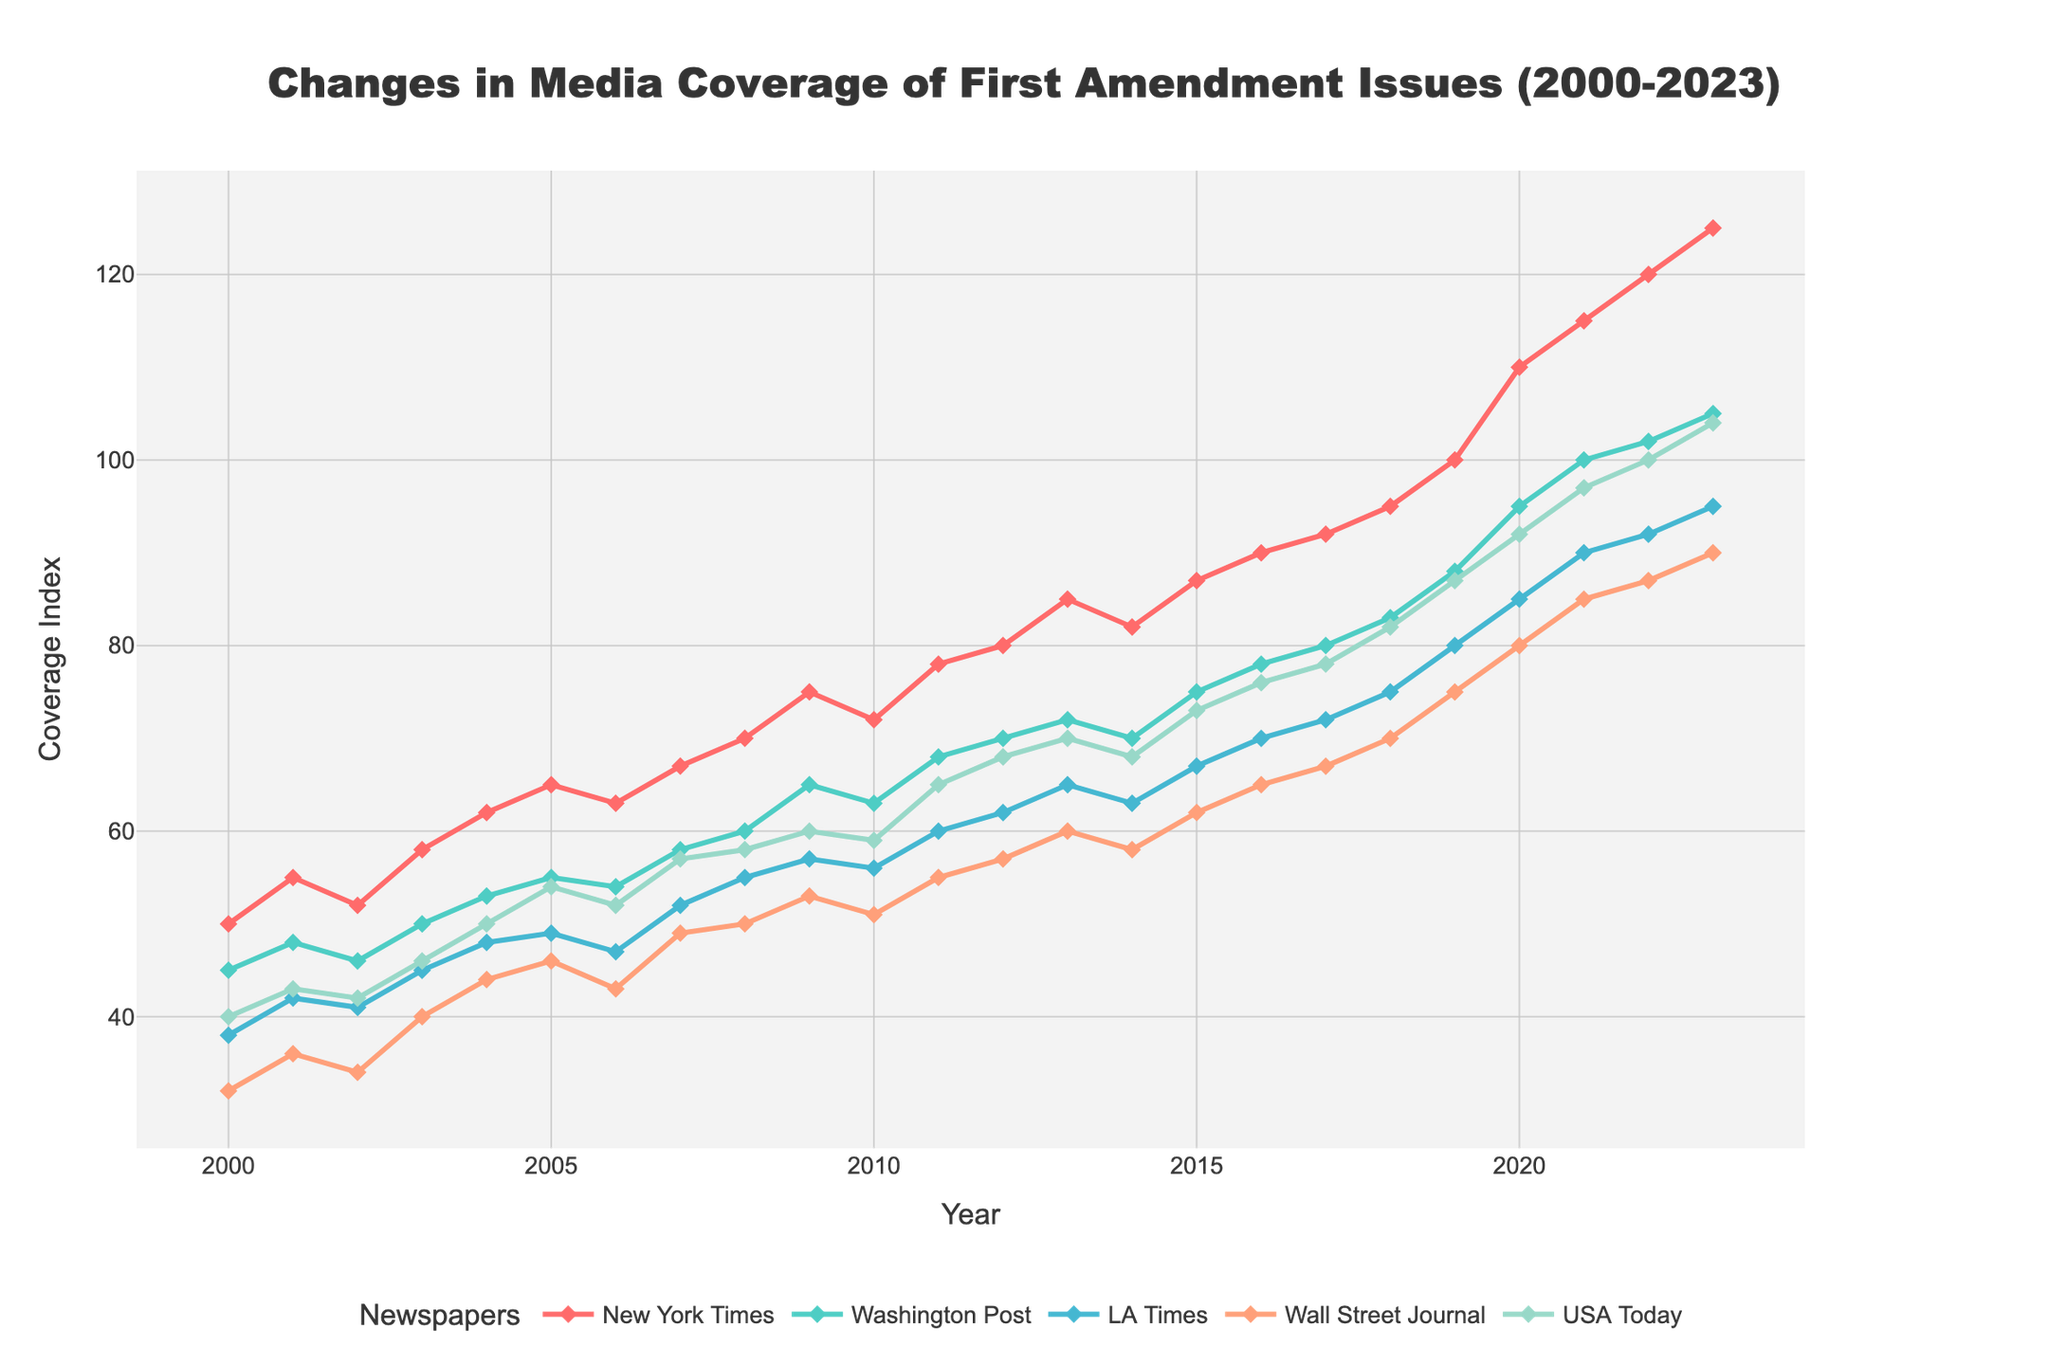what is the title of the plot? The title is located at the top of the plot and provides a summary of what the plot is about. It reads "Changes in Media Coverage of First Amendment Issues (2000-2023)".
Answer: Changes in Media Coverage of First Amendment Issues (2000-2023) What was the coverage index of the New York Times in 2005? Locate the year 2005 on the x-axis and trace it vertically to find the corresponding value for the New York Times, which is shown in red.
Answer: 65 Which newspaper had the highest coverage index in 2020? In 2020, you can compare all the lines and find that the highest point corresponds to the New York Times.
Answer: New York Times What is the overall trend in media coverage for the Washington Post from 2000 to 2023? Identify the line representing the Washington Post (color-coded) and note whether it is increasing, decreasing, or fluctuating over the years. The Washington Post shows a steady increase.
Answer: Increasing How does the coverage index of USA Today compare between 2005 and 2020? Locate both 2005 and 2020 on the x-axis and find the corresponding values for USA Today. Subtract the 2005 value from the 2020 value to see the change. USA Today's index increased from 54 in 2005 to 92 in 2020, indicating an increase of 38 points.
Answer: Increased by 38 points What was the average coverage index of the LA Times over the period from 2010 to 2020? Sum the coverage indices of the LA Times for the years between 2010 and 2020 and then divide by the number of years (11). The values are 56, 60, 62, 65, 63, 67, 70, 72, 75, 80, and 85. So, the average is (56+60+62+65+63+67+70+72+75+80+85)/11 ≈ 68.72
Answer: 68.72 Which newspapers showed the most significant increase in coverage from 2000 to 2023? Compare the coverage indices for all newspapers between 2000 and 2023 to determine the one with the highest index in 2023 and the increase from its 2000 value. The New York Times increased from 50 to 125, showing the highest increase of 75 points.
Answer: New York Times Has the Wall Street Journal consistently increased its coverage, or have there been fluctuations? Observe the trend of the line representing the Wall Street Journal over the years. The Wall Street Journal shows a general increase but with some minor fluctuations.
Answer: Minor fluctuations with a general increase Was there any year where the New York Times coverage dipped or remained constant compared to the previous year? Check the line corresponding to the New York Times to see if there were any years where it did not rise. Coverage dipped slightly between 2013 and 2014.
Answer: Yes, between 2013 and 2014 Which newspaper had the smallest coverage index in 2019? Comparing all the points for the year 2019 shows that the Wall Street Journal had the smallest coverage index among the newspapers.
Answer: Wall Street Journal 